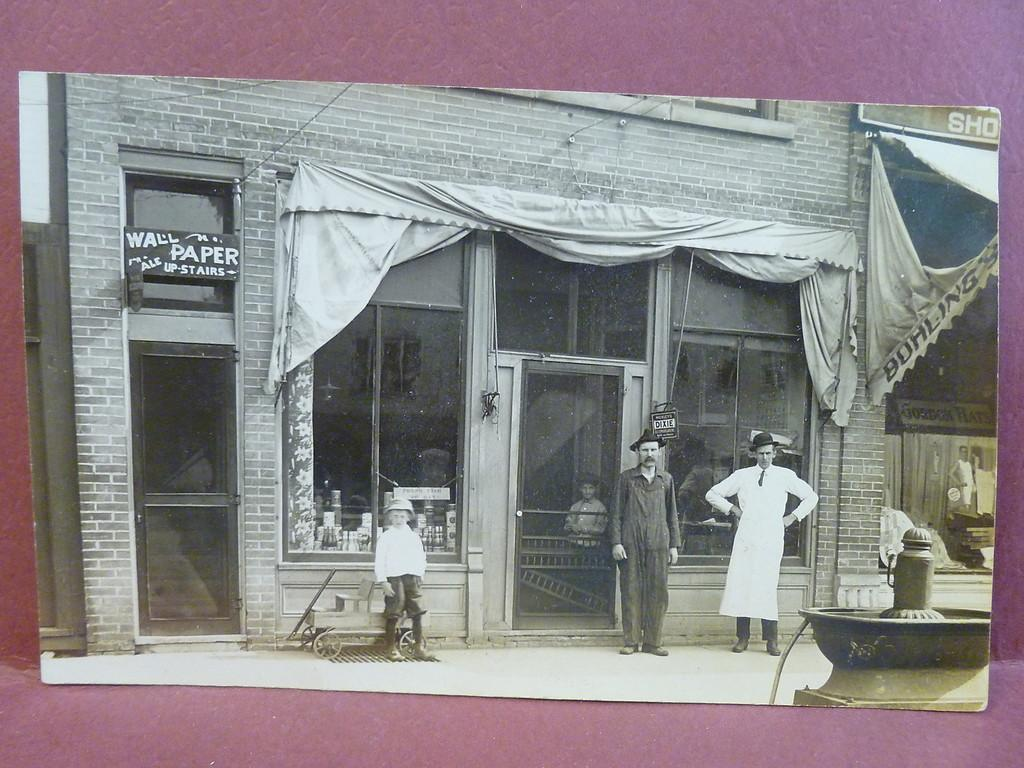What is the main subject of the image? There is a child in the image. How many adults are present in the image? There are two men standing in the image. What can be seen in the background of the image? There is a building in the background of the image. What type of architectural features are present in the image? There is a glass door and a glass window in the image. What can be seen inside the building? There are objects visible inside the building. How many fowl are visible in the image? There are no fowl present in the image. What type of linen is being used to cover the babies in the image? There are no babies present in the image, and therefore no linen is being used to cover them. 